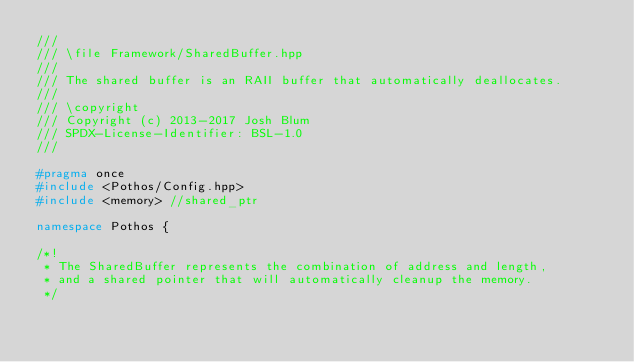<code> <loc_0><loc_0><loc_500><loc_500><_C++_>///
/// \file Framework/SharedBuffer.hpp
///
/// The shared buffer is an RAII buffer that automatically deallocates.
///
/// \copyright
/// Copyright (c) 2013-2017 Josh Blum
/// SPDX-License-Identifier: BSL-1.0
///

#pragma once
#include <Pothos/Config.hpp>
#include <memory> //shared_ptr

namespace Pothos {

/*!
 * The SharedBuffer represents the combination of address and length,
 * and a shared pointer that will automatically cleanup the memory.
 */</code> 